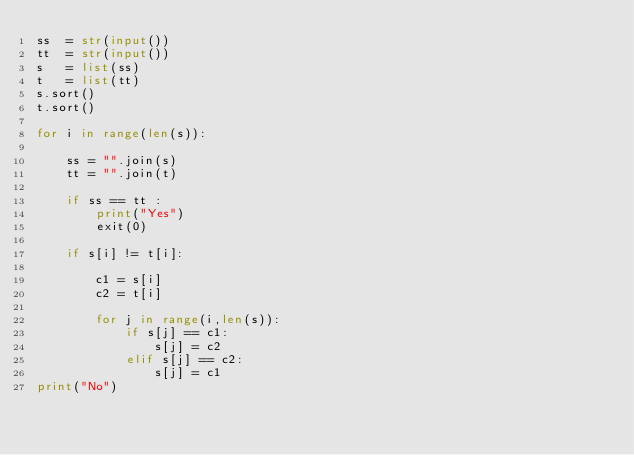<code> <loc_0><loc_0><loc_500><loc_500><_Python_>ss  = str(input())
tt  = str(input())
s   = list(ss)
t   = list(tt)
s.sort()
t.sort()

for i in range(len(s)):

    ss = "".join(s) 
    tt = "".join(t) 

    if ss == tt :
        print("Yes")
        exit(0)
 
    if s[i] != t[i]:
 
        c1 = s[i]
        c2 = t[i]

        for j in range(i,len(s)):
            if s[j] == c1:
                s[j] = c2
            elif s[j] == c2:
                s[j] = c1
print("No")</code> 